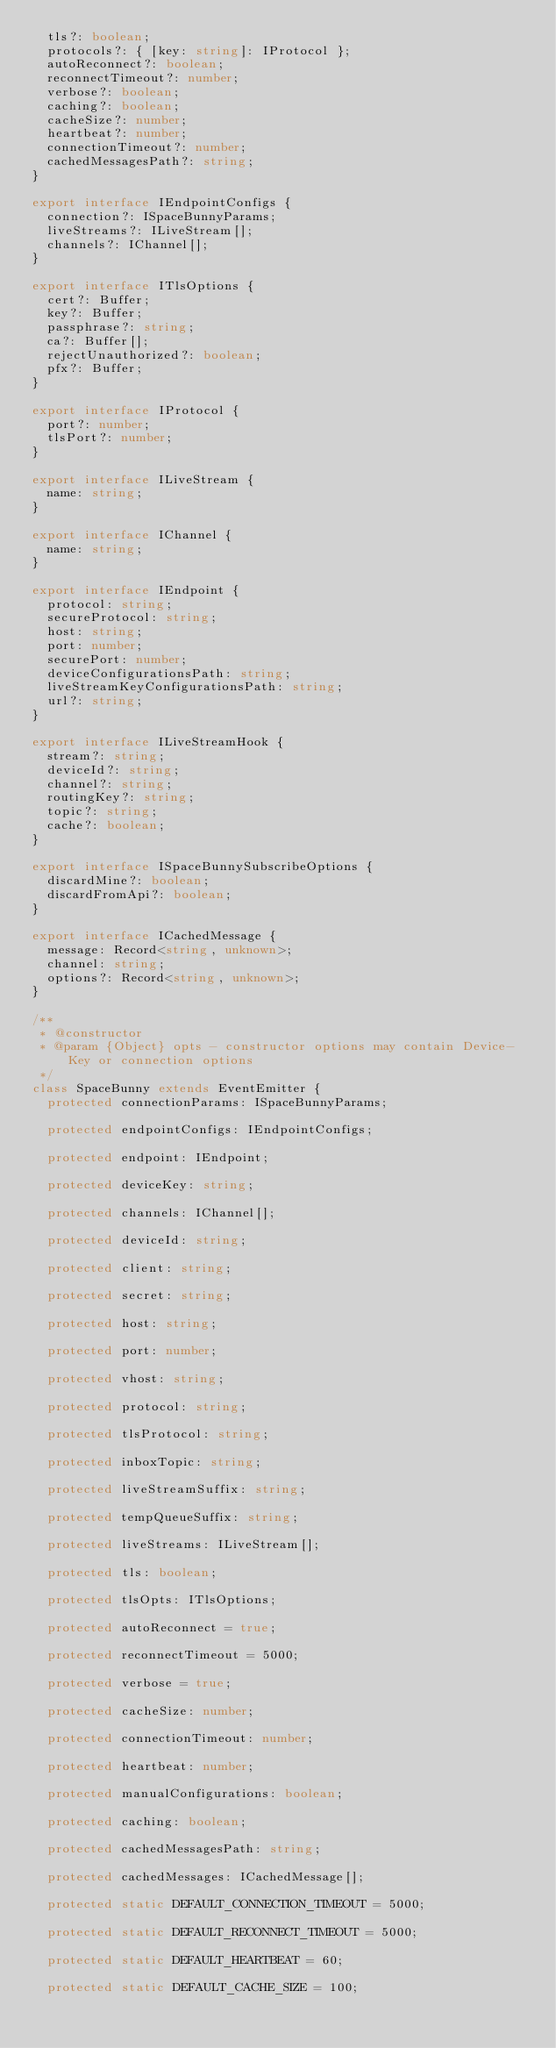<code> <loc_0><loc_0><loc_500><loc_500><_TypeScript_>  tls?: boolean;
  protocols?: { [key: string]: IProtocol };
  autoReconnect?: boolean;
  reconnectTimeout?: number;
  verbose?: boolean;
  caching?: boolean;
  cacheSize?: number;
  heartbeat?: number;
  connectionTimeout?: number;
  cachedMessagesPath?: string;
}

export interface IEndpointConfigs {
  connection?: ISpaceBunnyParams;
  liveStreams?: ILiveStream[];
  channels?: IChannel[];
}

export interface ITlsOptions {
  cert?: Buffer;
  key?: Buffer;
  passphrase?: string;
  ca?: Buffer[];
  rejectUnauthorized?: boolean;
  pfx?: Buffer;
}

export interface IProtocol {
  port?: number;
  tlsPort?: number;
}

export interface ILiveStream {
  name: string;
}

export interface IChannel {
  name: string;
}

export interface IEndpoint {
  protocol: string;
  secureProtocol: string;
  host: string;
  port: number;
  securePort: number;
  deviceConfigurationsPath: string;
  liveStreamKeyConfigurationsPath: string;
  url?: string;
}

export interface ILiveStreamHook {
  stream?: string;
  deviceId?: string;
  channel?: string;
  routingKey?: string;
  topic?: string;
  cache?: boolean;
}

export interface ISpaceBunnySubscribeOptions {
  discardMine?: boolean;
  discardFromApi?: boolean;
}

export interface ICachedMessage {
  message: Record<string, unknown>;
  channel: string;
  options?: Record<string, unknown>;
}

/**
 * @constructor
 * @param {Object} opts - constructor options may contain Device-Key or connection options
 */
class SpaceBunny extends EventEmitter {
  protected connectionParams: ISpaceBunnyParams;

  protected endpointConfigs: IEndpointConfigs;

  protected endpoint: IEndpoint;

  protected deviceKey: string;

  protected channels: IChannel[];

  protected deviceId: string;

  protected client: string;

  protected secret: string;

  protected host: string;

  protected port: number;

  protected vhost: string;

  protected protocol: string;

  protected tlsProtocol: string;

  protected inboxTopic: string;

  protected liveStreamSuffix: string;

  protected tempQueueSuffix: string;

  protected liveStreams: ILiveStream[];

  protected tls: boolean;

  protected tlsOpts: ITlsOptions;

  protected autoReconnect = true;

  protected reconnectTimeout = 5000;

  protected verbose = true;

  protected cacheSize: number;

  protected connectionTimeout: number;

  protected heartbeat: number;

  protected manualConfigurations: boolean;

  protected caching: boolean;

  protected cachedMessagesPath: string;

  protected cachedMessages: ICachedMessage[];

  protected static DEFAULT_CONNECTION_TIMEOUT = 5000;

  protected static DEFAULT_RECONNECT_TIMEOUT = 5000;

  protected static DEFAULT_HEARTBEAT = 60;

  protected static DEFAULT_CACHE_SIZE = 100;
</code> 